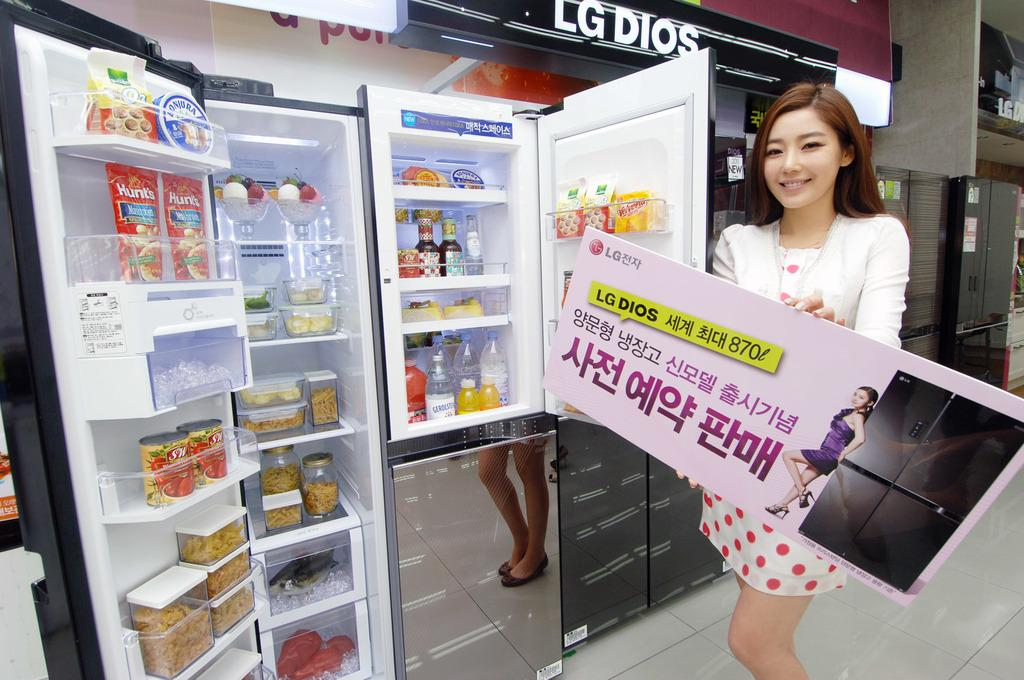Provide a one-sentence caption for the provided image. A woman displaying a refrigerator for sale in a store. 